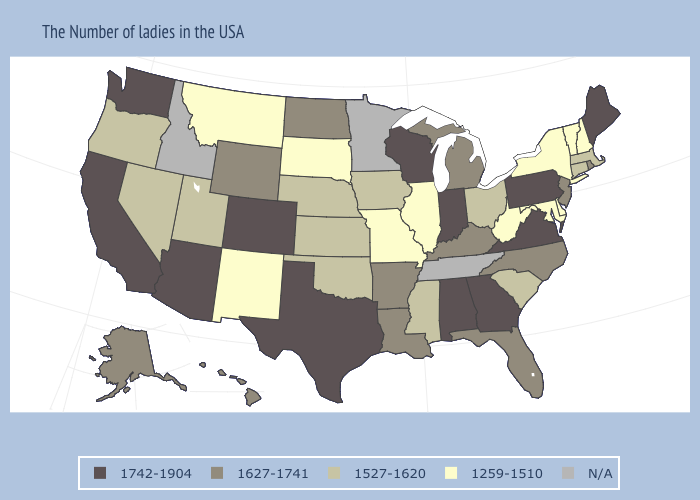What is the lowest value in the MidWest?
Write a very short answer. 1259-1510. What is the lowest value in the West?
Give a very brief answer. 1259-1510. Does California have the lowest value in the West?
Keep it brief. No. What is the value of New Hampshire?
Answer briefly. 1259-1510. What is the value of New Hampshire?
Write a very short answer. 1259-1510. Name the states that have a value in the range 1259-1510?
Quick response, please. New Hampshire, Vermont, New York, Delaware, Maryland, West Virginia, Illinois, Missouri, South Dakota, New Mexico, Montana. Name the states that have a value in the range N/A?
Quick response, please. Tennessee, Minnesota, Idaho. Does Michigan have the highest value in the USA?
Be succinct. No. Is the legend a continuous bar?
Keep it brief. No. What is the value of Washington?
Be succinct. 1742-1904. Does the first symbol in the legend represent the smallest category?
Keep it brief. No. What is the lowest value in the West?
Give a very brief answer. 1259-1510. What is the highest value in the USA?
Keep it brief. 1742-1904. Is the legend a continuous bar?
Keep it brief. No. 